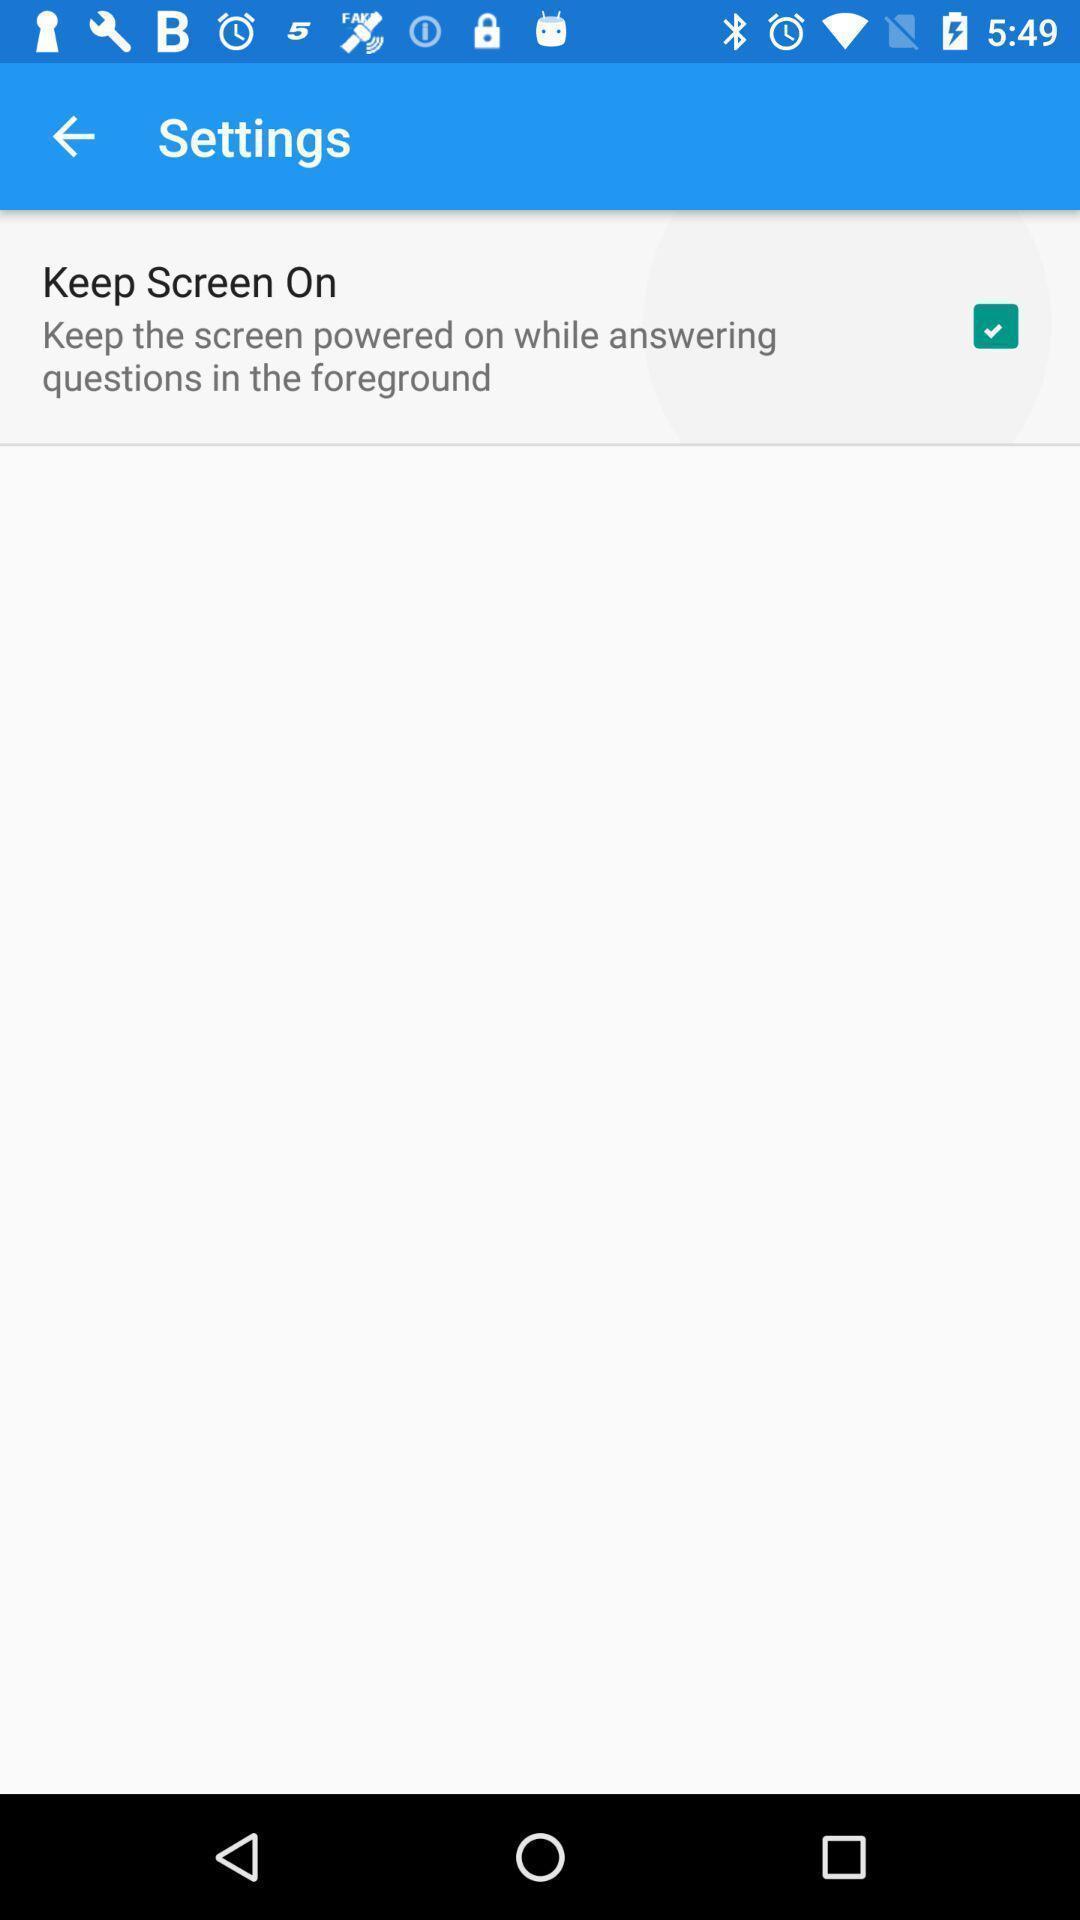What details can you identify in this image? Screen shows settings. 